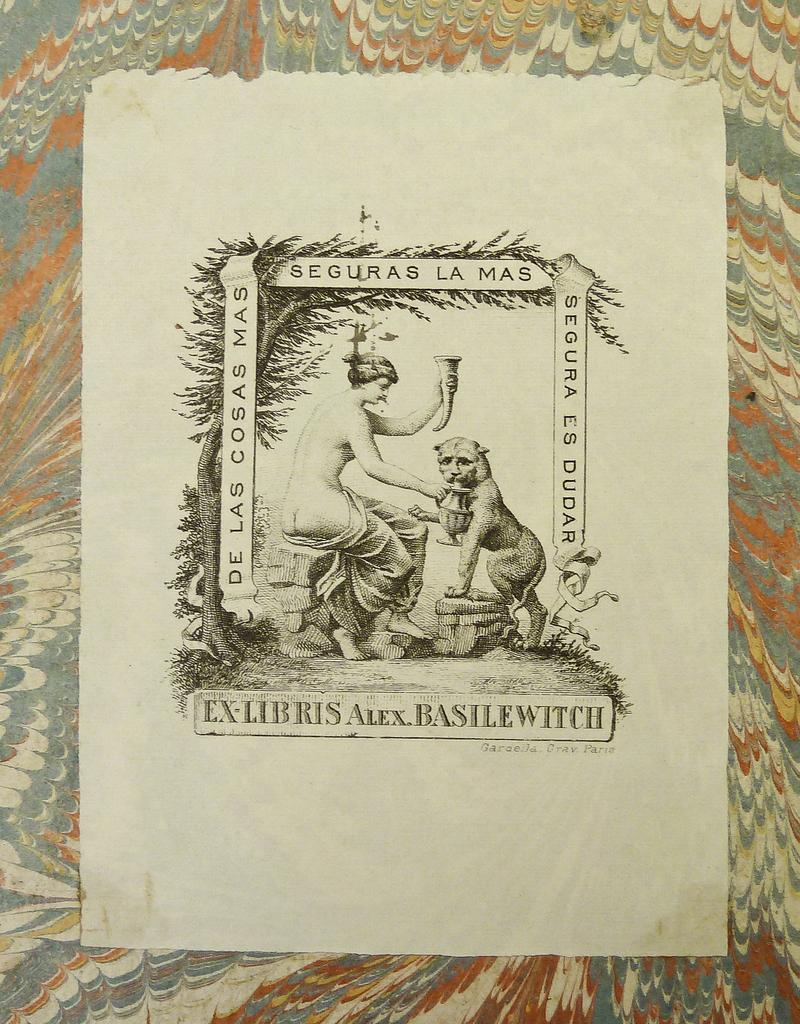Provide a one-sentence caption for the provided image. a picture of a woman and a beast with the word EX-LIBRIS on it. 